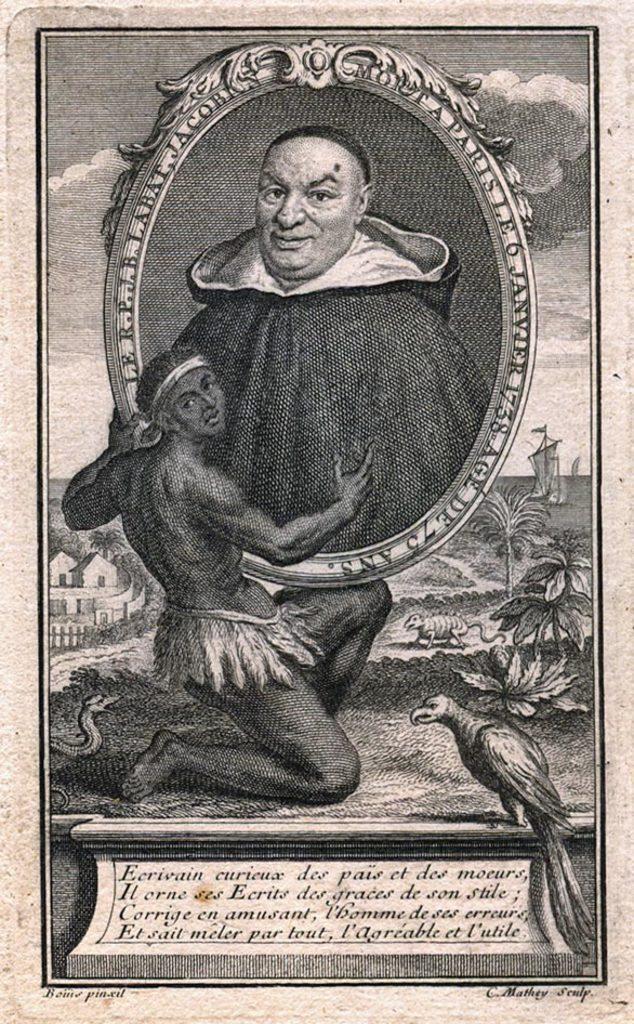How would you summarize this image in a sentence or two? In the image there is a paper. At the bottom of the paper there is an object with text on it. Above the object there is a man holding a frame in his hands. In that frame there is an image of a man. And in the image there is a bird, snake and another animal. And also there are trees and also buildings. There is sky with clouds. 